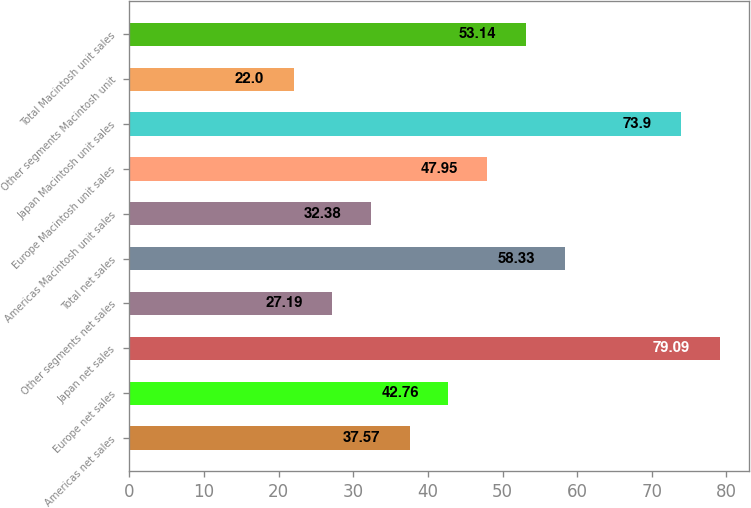Convert chart. <chart><loc_0><loc_0><loc_500><loc_500><bar_chart><fcel>Americas net sales<fcel>Europe net sales<fcel>Japan net sales<fcel>Other segments net sales<fcel>Total net sales<fcel>Americas Macintosh unit sales<fcel>Europe Macintosh unit sales<fcel>Japan Macintosh unit sales<fcel>Other segments Macintosh unit<fcel>Total Macintosh unit sales<nl><fcel>37.57<fcel>42.76<fcel>79.09<fcel>27.19<fcel>58.33<fcel>32.38<fcel>47.95<fcel>73.9<fcel>22<fcel>53.14<nl></chart> 